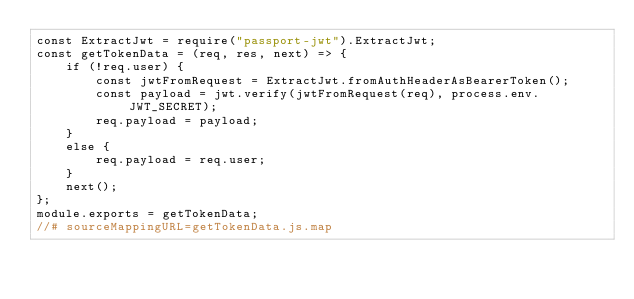Convert code to text. <code><loc_0><loc_0><loc_500><loc_500><_JavaScript_>const ExtractJwt = require("passport-jwt").ExtractJwt;
const getTokenData = (req, res, next) => {
    if (!req.user) {
        const jwtFromRequest = ExtractJwt.fromAuthHeaderAsBearerToken();
        const payload = jwt.verify(jwtFromRequest(req), process.env.JWT_SECRET);
        req.payload = payload;
    }
    else {
        req.payload = req.user;
    }
    next();
};
module.exports = getTokenData;
//# sourceMappingURL=getTokenData.js.map</code> 